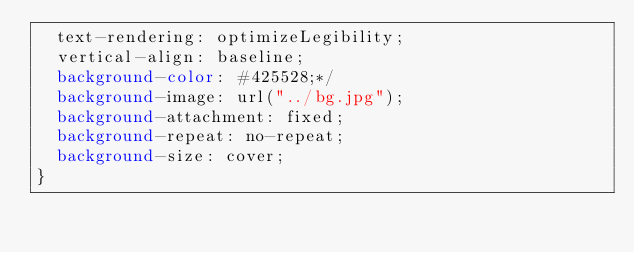Convert code to text. <code><loc_0><loc_0><loc_500><loc_500><_CSS_>  text-rendering: optimizeLegibility;
  vertical-align: baseline;
  background-color: #425528;*/
  background-image: url("../bg.jpg");
  background-attachment: fixed;
  background-repeat: no-repeat;
  background-size: cover;
}

</code> 